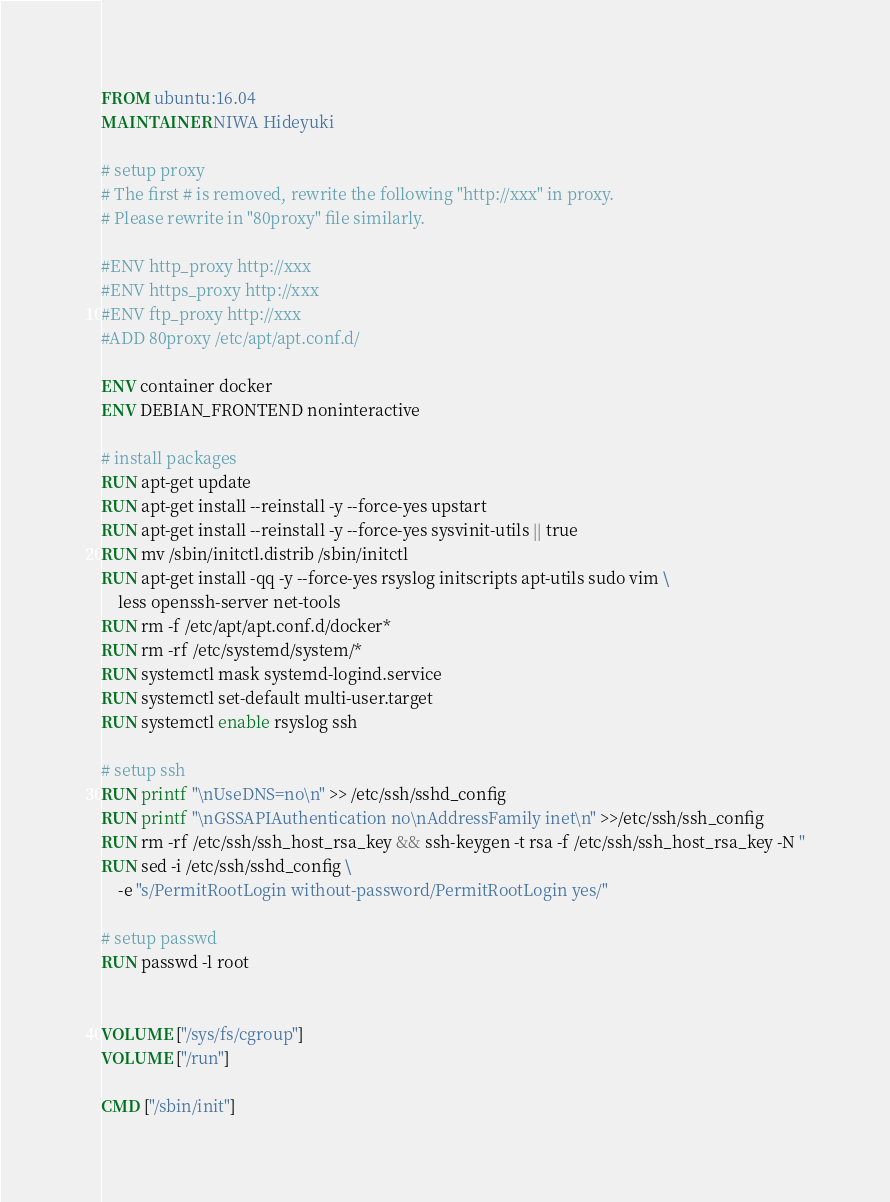<code> <loc_0><loc_0><loc_500><loc_500><_Dockerfile_>FROM ubuntu:16.04
MAINTAINER NIWA Hideyuki

# setup proxy
# The first # is removed, rewrite the following "http://xxx" in proxy. 
# Please rewrite in "80proxy" file similarly. 

#ENV http_proxy http://xxx
#ENV https_proxy http://xxx
#ENV ftp_proxy http://xxx
#ADD 80proxy /etc/apt/apt.conf.d/

ENV container docker
ENV DEBIAN_FRONTEND noninteractive

# install packages
RUN apt-get update 
RUN apt-get install --reinstall -y --force-yes upstart
RUN apt-get install --reinstall -y --force-yes sysvinit-utils || true
RUN mv /sbin/initctl.distrib /sbin/initctl
RUN apt-get install -qq -y --force-yes rsyslog initscripts apt-utils sudo vim \
	less openssh-server net-tools
RUN rm -f /etc/apt/apt.conf.d/docker*
RUN rm -rf /etc/systemd/system/*
RUN systemctl mask systemd-logind.service
RUN systemctl set-default multi-user.target
RUN systemctl enable rsyslog ssh

# setup ssh
RUN printf "\nUseDNS=no\n" >> /etc/ssh/sshd_config
RUN printf "\nGSSAPIAuthentication no\nAddressFamily inet\n" >>/etc/ssh/ssh_config
RUN rm -rf /etc/ssh/ssh_host_rsa_key && ssh-keygen -t rsa -f /etc/ssh/ssh_host_rsa_key -N ''
RUN sed -i /etc/ssh/sshd_config \
	-e "s/PermitRootLogin without-password/PermitRootLogin yes/"

# setup passwd
RUN passwd -l root


VOLUME ["/sys/fs/cgroup"]
VOLUME ["/run"]

CMD ["/sbin/init"]

</code> 